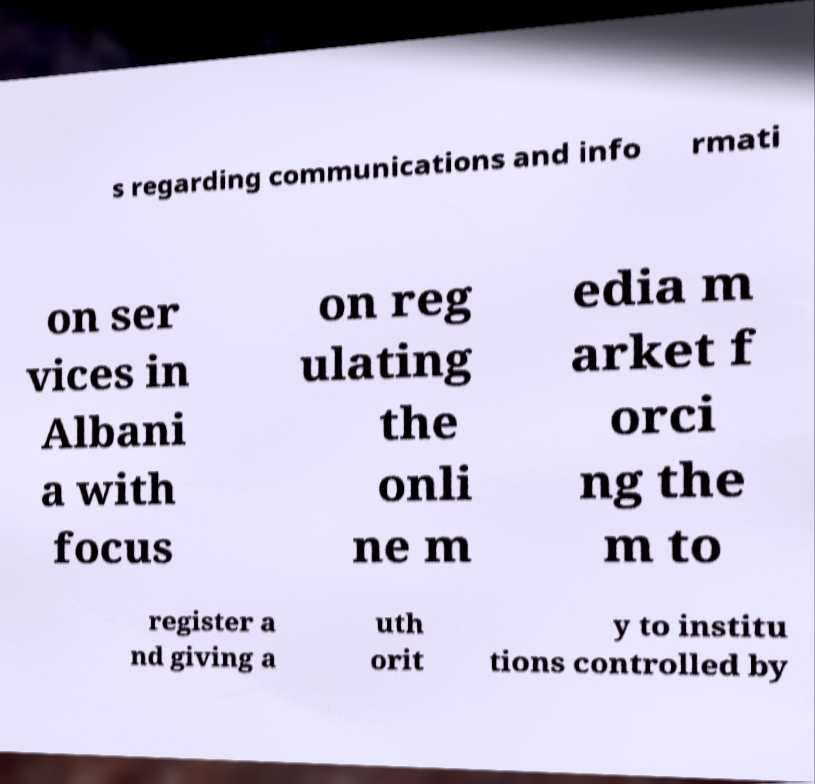I need the written content from this picture converted into text. Can you do that? s regarding communications and info rmati on ser vices in Albani a with focus on reg ulating the onli ne m edia m arket f orci ng the m to register a nd giving a uth orit y to institu tions controlled by 